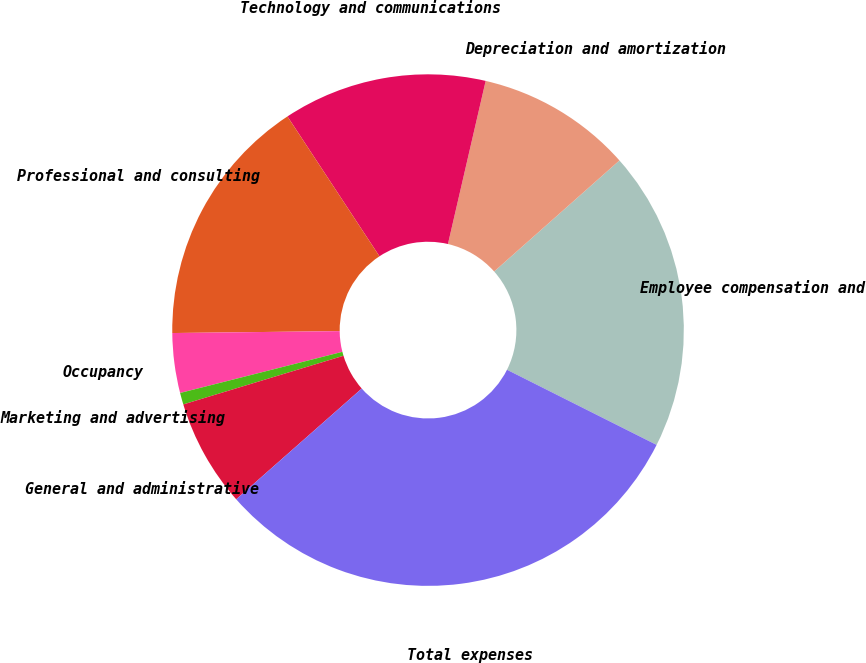<chart> <loc_0><loc_0><loc_500><loc_500><pie_chart><fcel>Employee compensation and<fcel>Depreciation and amortization<fcel>Technology and communications<fcel>Professional and consulting<fcel>Occupancy<fcel>Marketing and advertising<fcel>General and administrative<fcel>Total expenses<nl><fcel>18.95%<fcel>9.84%<fcel>12.88%<fcel>15.92%<fcel>3.77%<fcel>0.74%<fcel>6.81%<fcel>31.09%<nl></chart> 